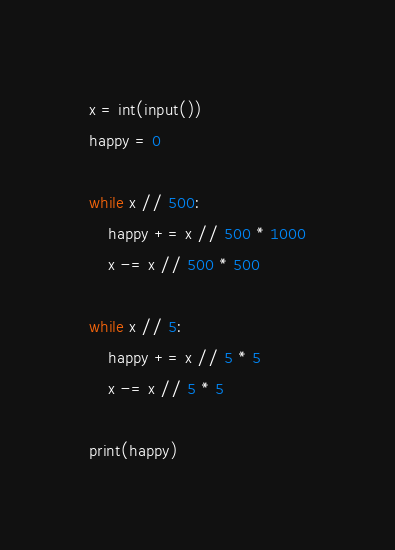<code> <loc_0><loc_0><loc_500><loc_500><_Python_>x = int(input())
happy = 0

while x // 500:
    happy += x // 500 * 1000
    x -= x // 500 * 500

while x // 5:
    happy += x // 5 * 5
    x -= x // 5 * 5

print(happy)

</code> 